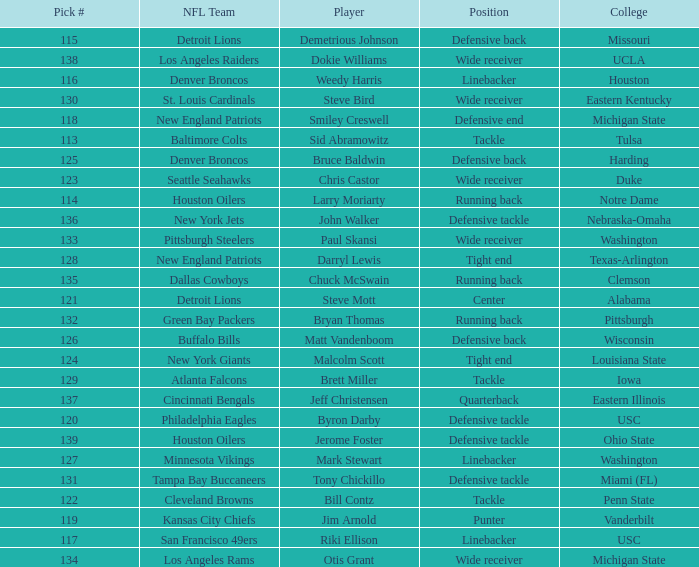What pick number did the buffalo bills get? 126.0. 